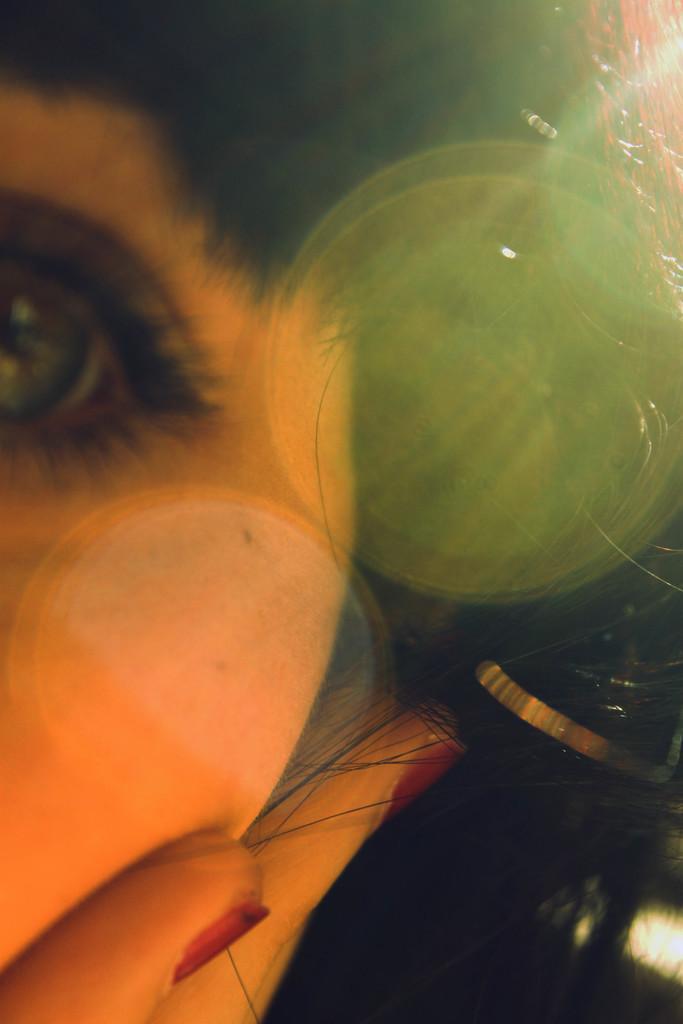Could you give a brief overview of what you see in this image? In this image I can see a human eye and a human hand on this person's face. 